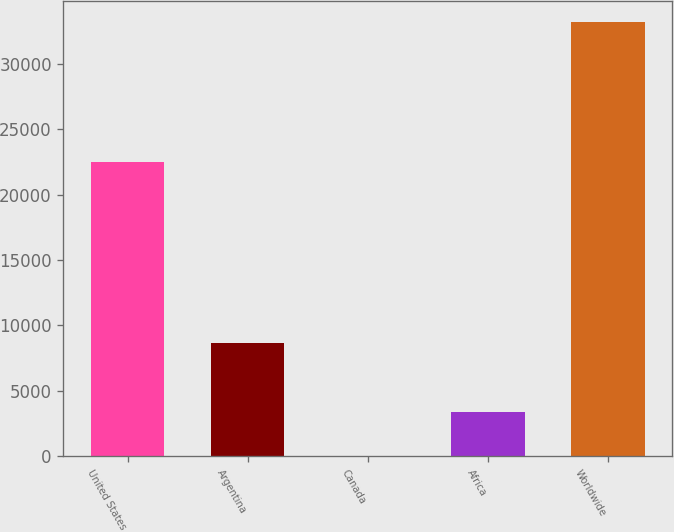Convert chart. <chart><loc_0><loc_0><loc_500><loc_500><bar_chart><fcel>United States<fcel>Argentina<fcel>Canada<fcel>Africa<fcel>Worldwide<nl><fcel>22509<fcel>8687<fcel>35<fcel>3352.7<fcel>33212<nl></chart> 